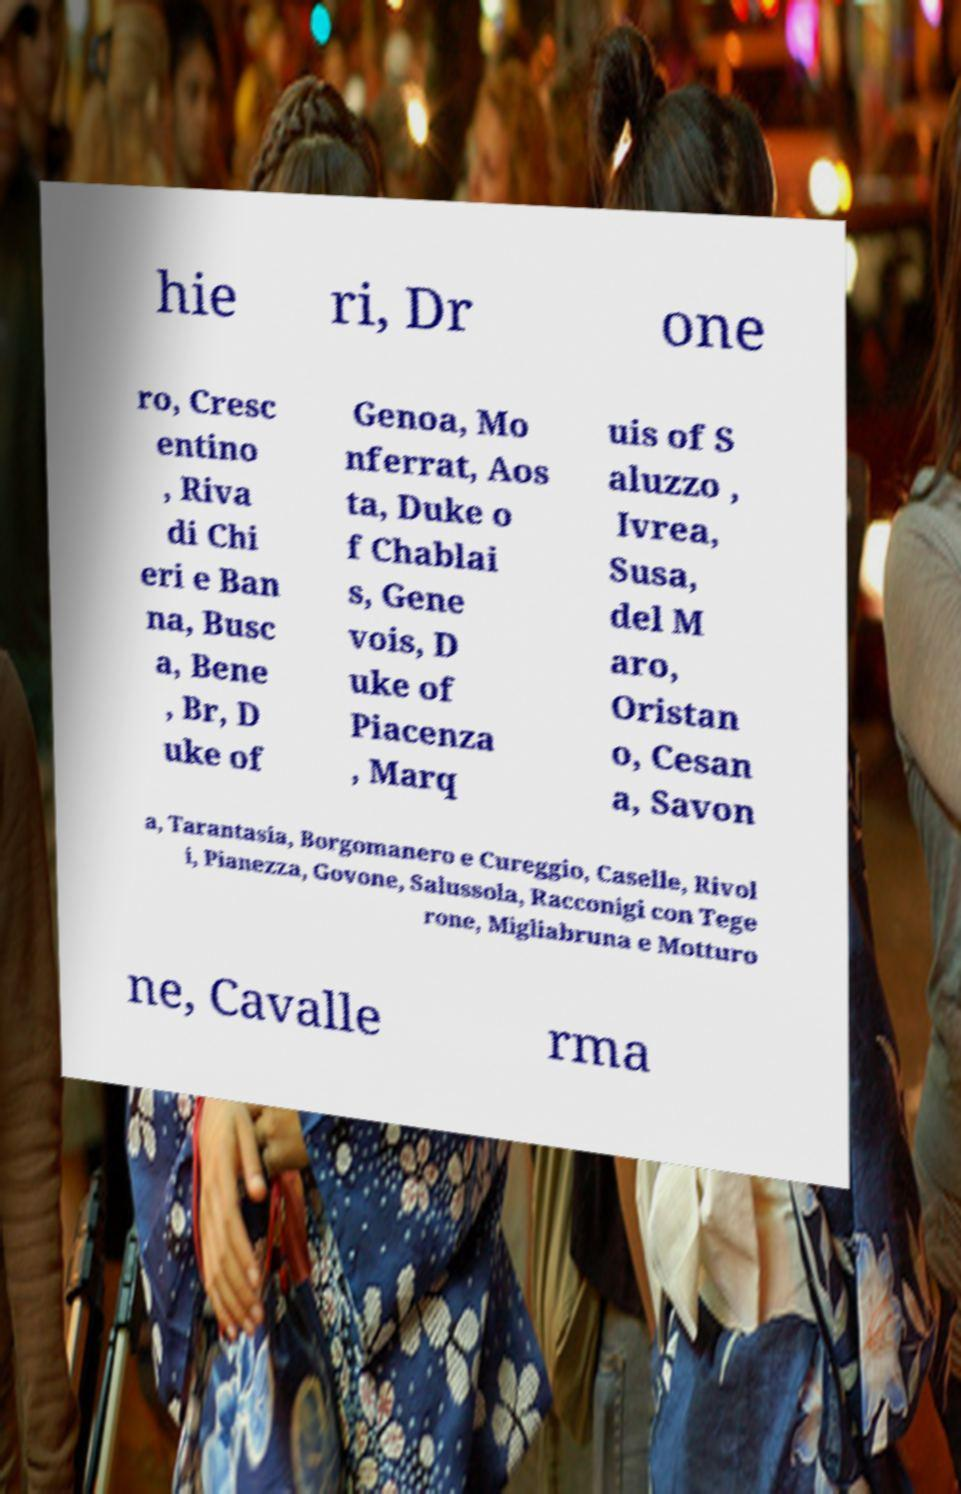Please identify and transcribe the text found in this image. hie ri, Dr one ro, Cresc entino , Riva di Chi eri e Ban na, Busc a, Bene , Br, D uke of Genoa, Mo nferrat, Aos ta, Duke o f Chablai s, Gene vois, D uke of Piacenza , Marq uis of S aluzzo , Ivrea, Susa, del M aro, Oristan o, Cesan a, Savon a, Tarantasia, Borgomanero e Cureggio, Caselle, Rivol i, Pianezza, Govone, Salussola, Racconigi con Tege rone, Migliabruna e Motturo ne, Cavalle rma 